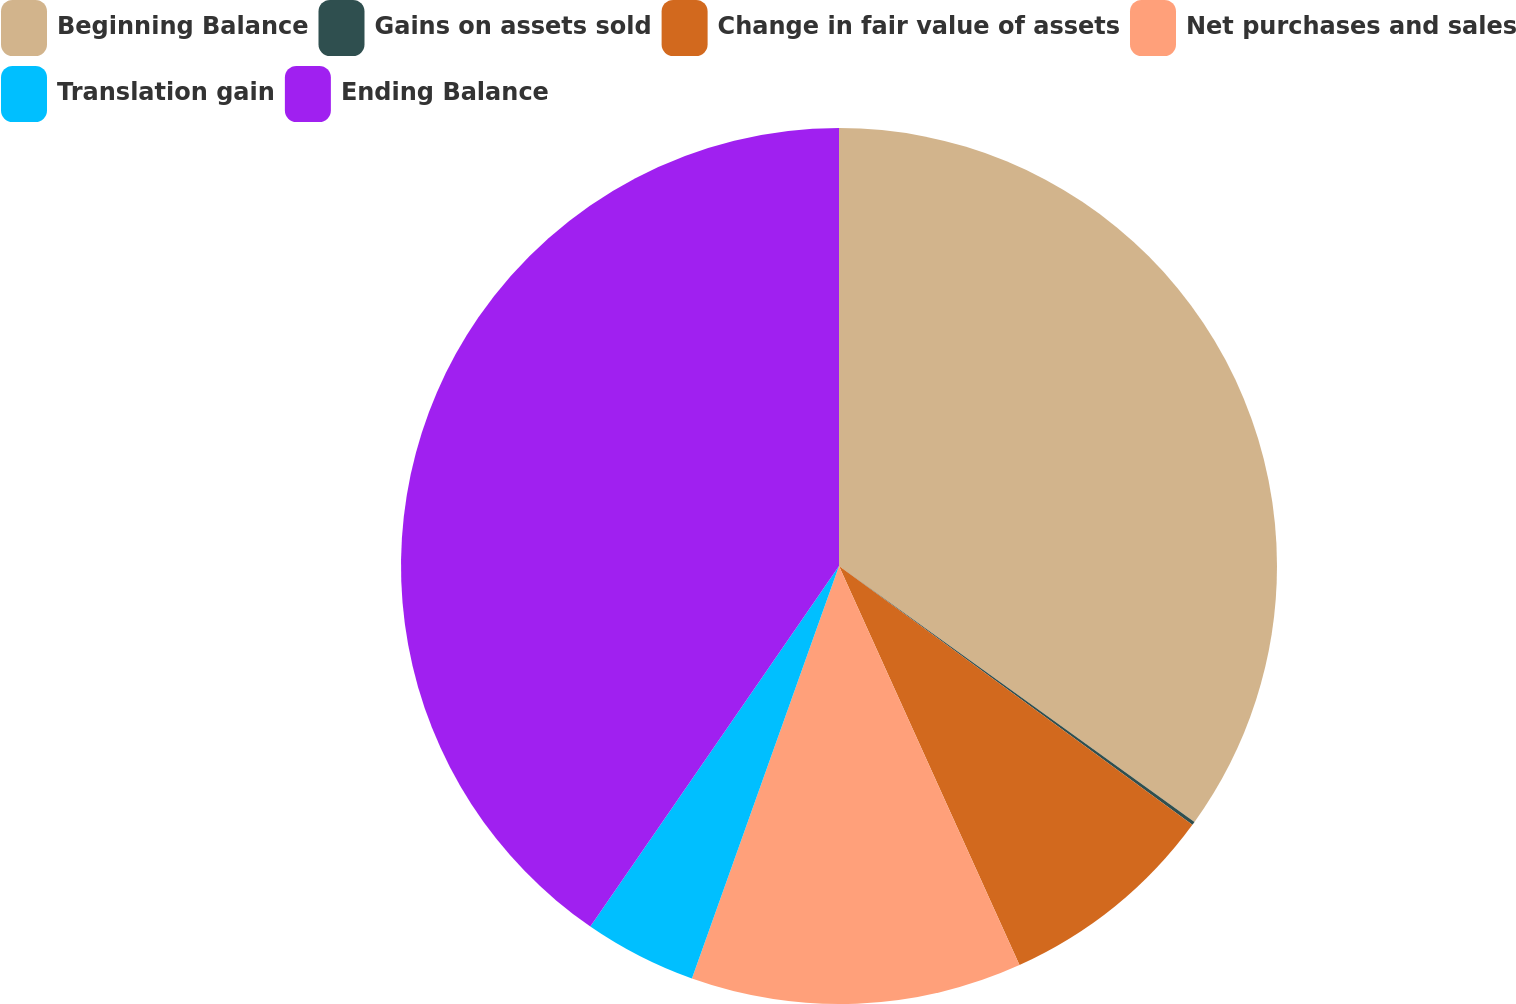Convert chart to OTSL. <chart><loc_0><loc_0><loc_500><loc_500><pie_chart><fcel>Beginning Balance<fcel>Gains on assets sold<fcel>Change in fair value of assets<fcel>Net purchases and sales<fcel>Translation gain<fcel>Ending Balance<nl><fcel>34.93%<fcel>0.13%<fcel>8.18%<fcel>12.21%<fcel>4.16%<fcel>40.39%<nl></chart> 